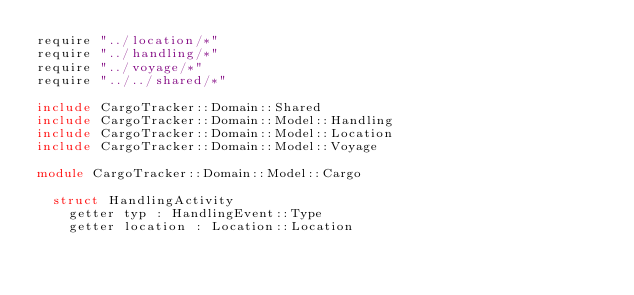<code> <loc_0><loc_0><loc_500><loc_500><_Crystal_>require "../location/*"
require "../handling/*"
require "../voyage/*"
require "../../shared/*"

include CargoTracker::Domain::Shared
include CargoTracker::Domain::Model::Handling
include CargoTracker::Domain::Model::Location
include CargoTracker::Domain::Model::Voyage

module CargoTracker::Domain::Model::Cargo

  struct HandlingActivity
    getter typ : HandlingEvent::Type
    getter location : Location::Location</code> 